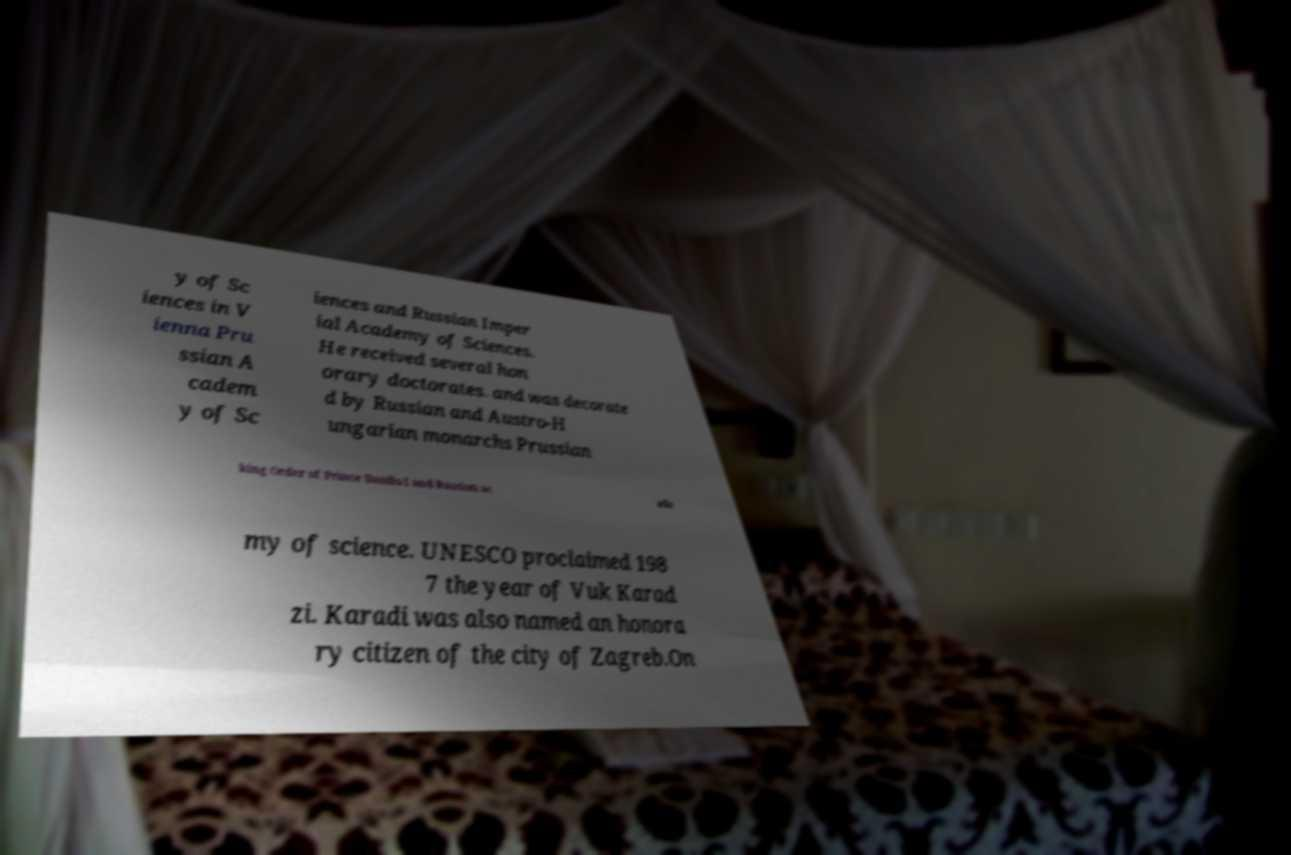Could you extract and type out the text from this image? y of Sc iences in V ienna Pru ssian A cadem y of Sc iences and Russian Imper ial Academy of Sciences. He received several hon orary doctorates. and was decorate d by Russian and Austro-H ungarian monarchs Prussian king Order of Prince Danilo I and Russian ac ade my of science. UNESCO proclaimed 198 7 the year of Vuk Karad zi. Karadi was also named an honora ry citizen of the city of Zagreb.On 